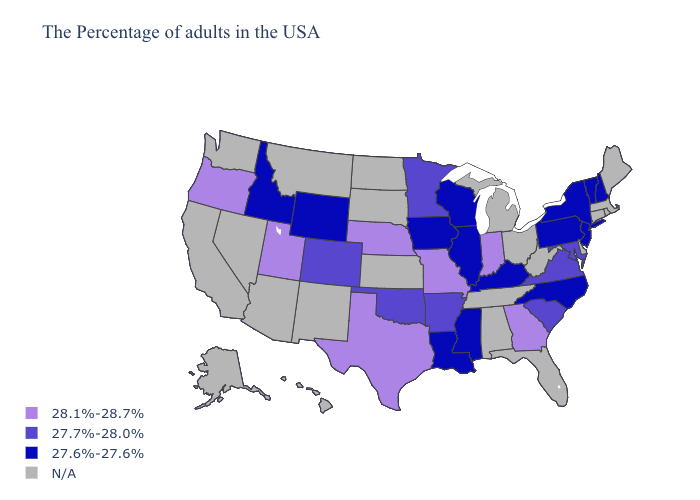Name the states that have a value in the range 28.1%-28.7%?
Keep it brief. Georgia, Indiana, Missouri, Nebraska, Texas, Utah, Oregon. Is the legend a continuous bar?
Quick response, please. No. What is the lowest value in states that border Florida?
Answer briefly. 28.1%-28.7%. What is the value of New York?
Give a very brief answer. 27.6%-27.6%. Which states have the highest value in the USA?
Short answer required. Georgia, Indiana, Missouri, Nebraska, Texas, Utah, Oregon. What is the value of Wisconsin?
Short answer required. 27.6%-27.6%. Name the states that have a value in the range 27.7%-28.0%?
Write a very short answer. Maryland, Virginia, South Carolina, Arkansas, Minnesota, Oklahoma, Colorado. Which states hav the highest value in the West?
Keep it brief. Utah, Oregon. What is the highest value in the West ?
Keep it brief. 28.1%-28.7%. Among the states that border Indiana , which have the highest value?
Short answer required. Kentucky, Illinois. Which states have the highest value in the USA?
Answer briefly. Georgia, Indiana, Missouri, Nebraska, Texas, Utah, Oregon. Name the states that have a value in the range 27.7%-28.0%?
Write a very short answer. Maryland, Virginia, South Carolina, Arkansas, Minnesota, Oklahoma, Colorado. Name the states that have a value in the range 27.6%-27.6%?
Concise answer only. New Hampshire, Vermont, New York, New Jersey, Pennsylvania, North Carolina, Kentucky, Wisconsin, Illinois, Mississippi, Louisiana, Iowa, Wyoming, Idaho. 